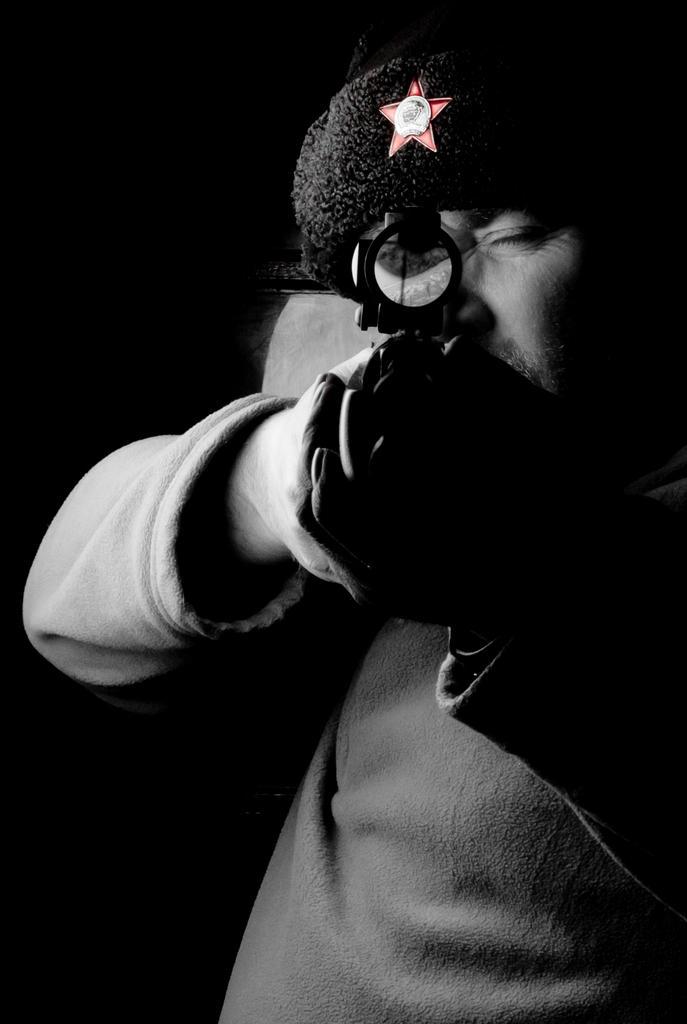Could you give a brief overview of what you see in this image? In the center of the image there is a person wearing a cap. He is holding a gun. 